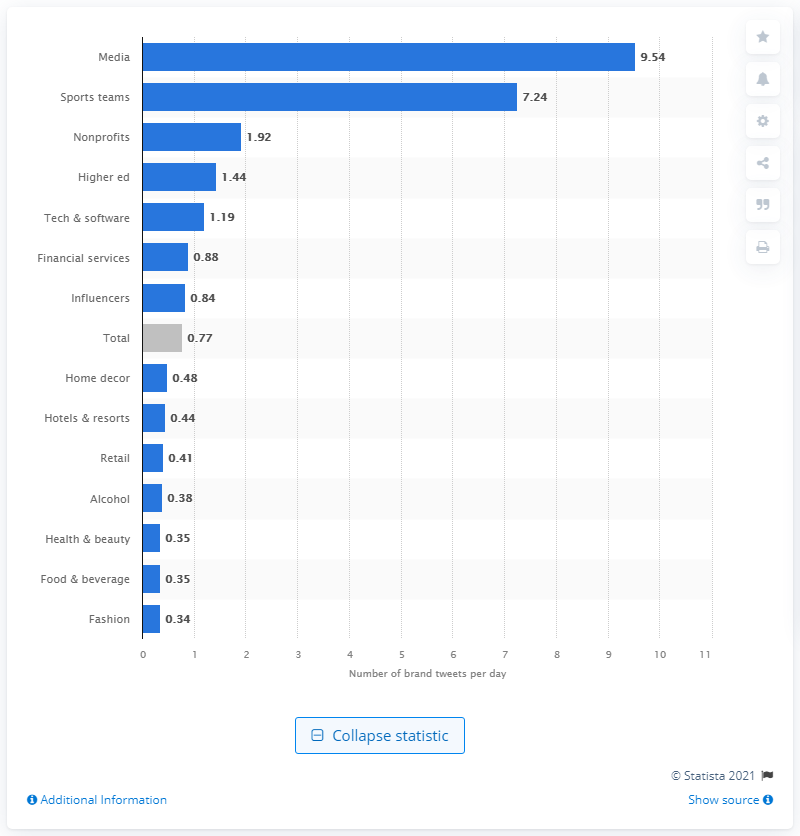Draw attention to some important aspects in this diagram. On average, retail brands tweeted 0.41 times per day. The average number of tweets made by a leading media brand per day is 9.54. 